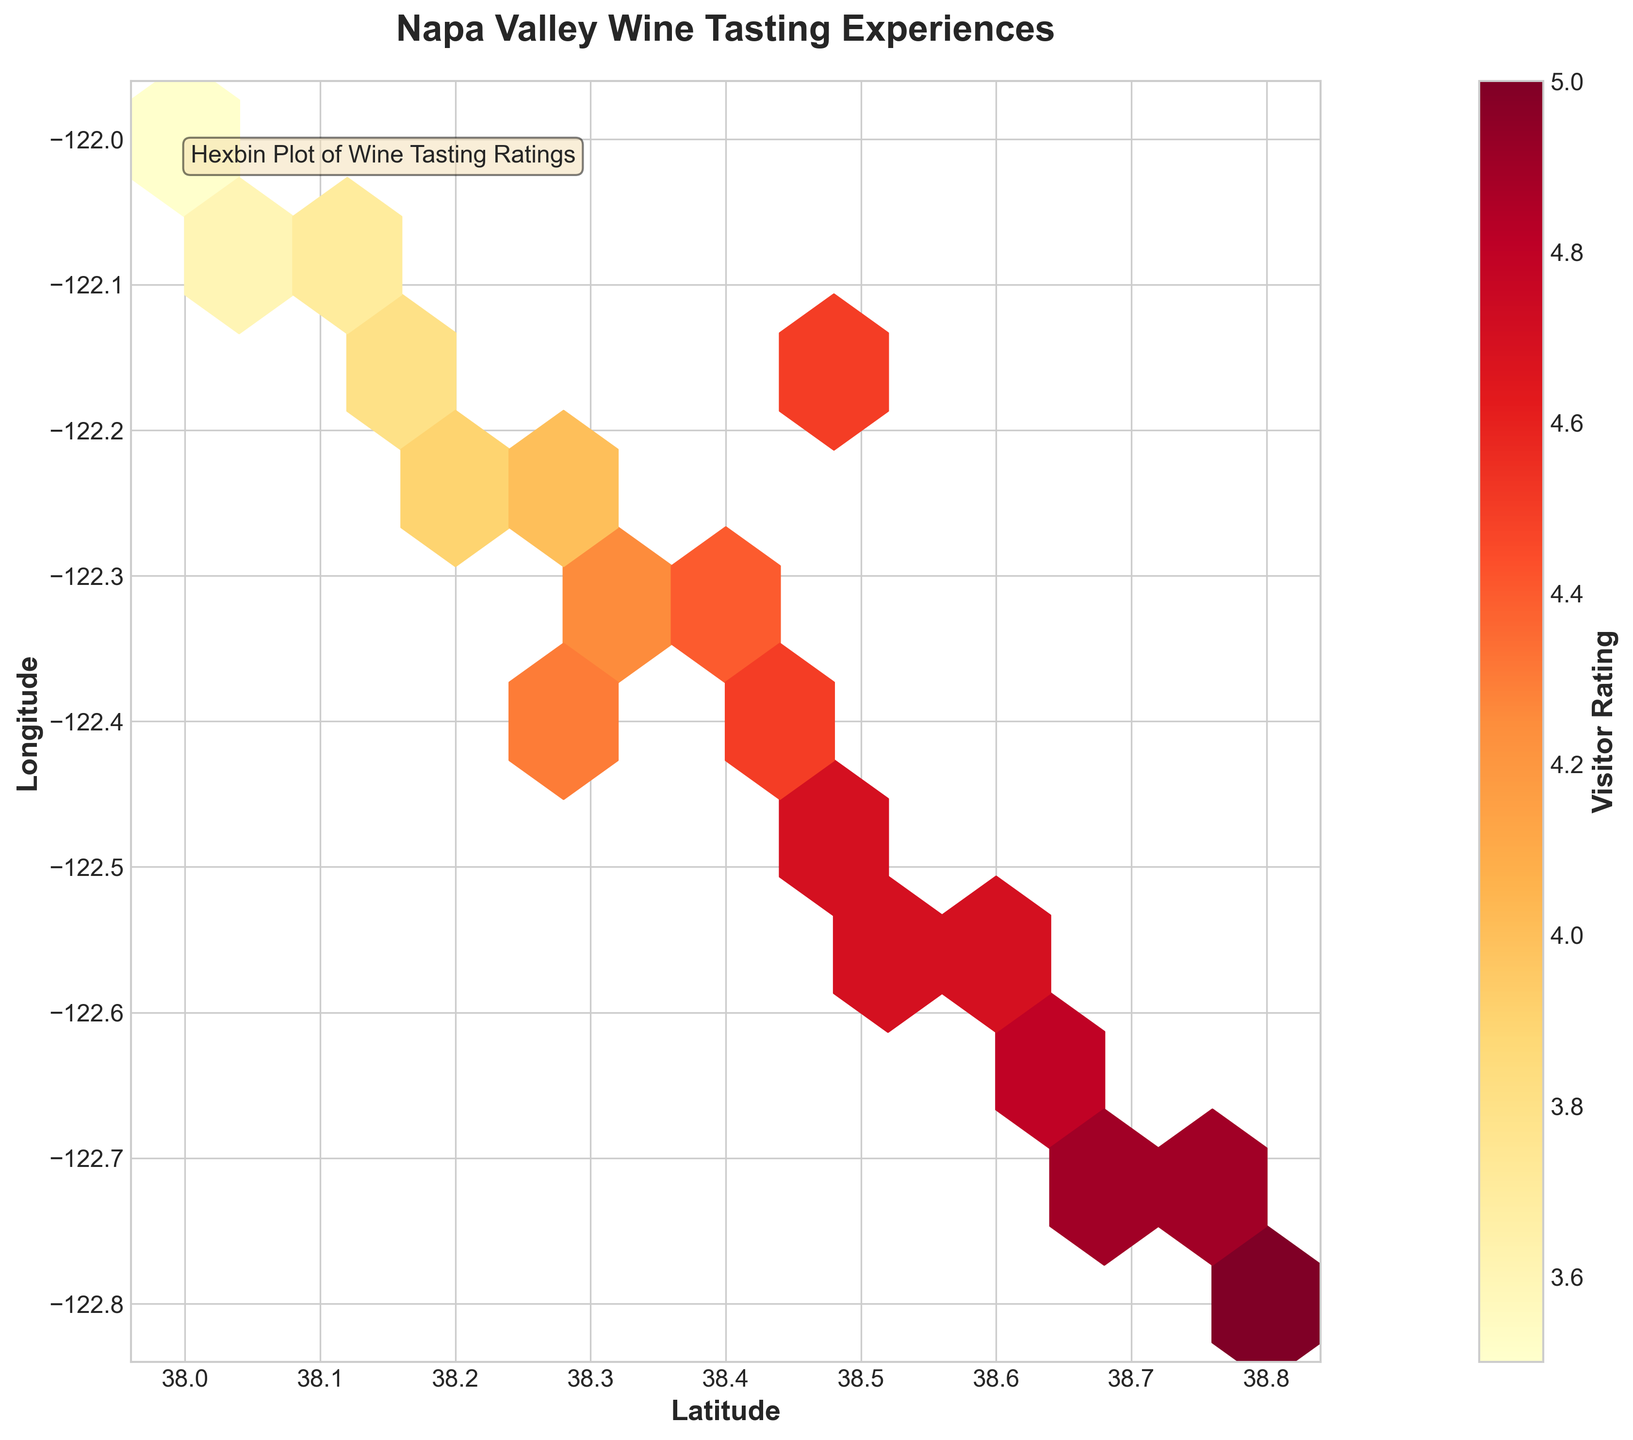What is the title of the plot? Look at the top part of the figure where the title is usually placed. It is labeled in bold and larger font.
Answer: Napa Valley Wine Tasting Experiences What are the labels for the x and y axes? Look at the text next to the horizontal line for the x-axis and the vertical line for the y-axis. These labels are in bold font.
Answer: Latitude, Longitude What does the color represent in the hexbin plot? Check the legend or colorbar on the right side of the figure, which indicates what the colors correspond to.
Answer: Visitor Rating What color represents the highest visitor rating? Observe the color gradient in the colorbar; the color at the top of the gradient corresponds to the highest rating.
Answer: Dark red Which region has the highest density of wine tastings? Look for the hexbin cell with the highest color intensity (dark red or orange), indicating a high density of data points.
Answer: Around (38.4, -122.4) What is the general trend between latitude and visitor ratings? Observe how the colors change as you move from lower to higher latitudes. If the highest ratings (dark red) cluster in a particular direction, that forms a trend.
Answer: Higher latitudes generally have higher ratings Are the ratings more concentrated in any particular longitude range? Check the concentration of hexbin cells along the y-axis (longitude) with similar colors, especially those representing higher ratings (red/orange).
Answer: Yes, ratings seem concentrated around longitudes -122.4 to -122.5 Which exact latitude and longitude has a rating of 5.0? Identify the exact position of the hexbin cell that matches the color representing the highest rating on the colorbar.
Answer: (38.8, -122.8) How does the plot indicate the frequency of tastings? Describe what the density of the hexbin cells represents. More cells or more intense colors indicate higher frequencies.
Answer: Higher density of hex cells and more intense colors indicate higher frequency of tastings What might be an area with fewer wine tasting experiences but still high ratings? Look for isolated hexbin cells that are dark red or orange but not part of a cluster, suggesting fewer tastings but high ratings.
Answer: Around (38.25, -122.25) 